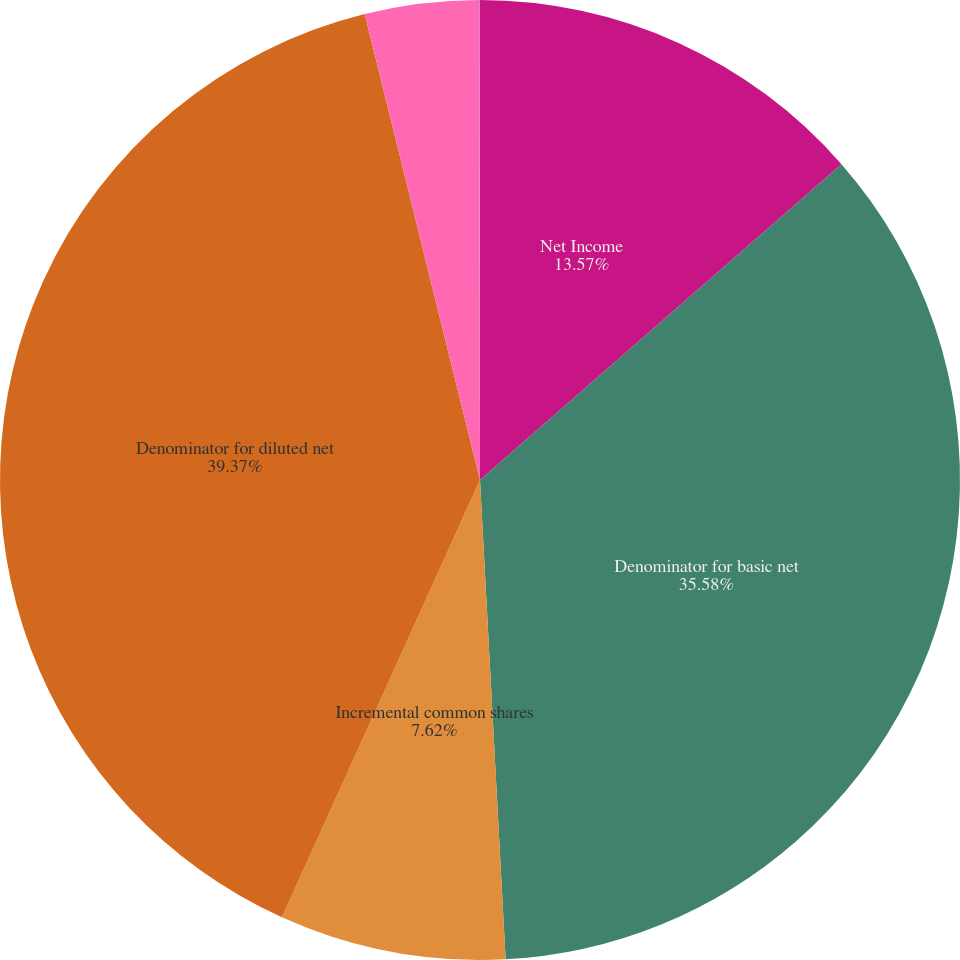Convert chart to OTSL. <chart><loc_0><loc_0><loc_500><loc_500><pie_chart><fcel>Net Income<fcel>Denominator for basic net<fcel>Incremental common shares<fcel>Denominator for diluted net<fcel>Basic net income per share<fcel>Diluted net income per share<nl><fcel>13.57%<fcel>35.58%<fcel>7.62%<fcel>39.37%<fcel>3.83%<fcel>0.03%<nl></chart> 